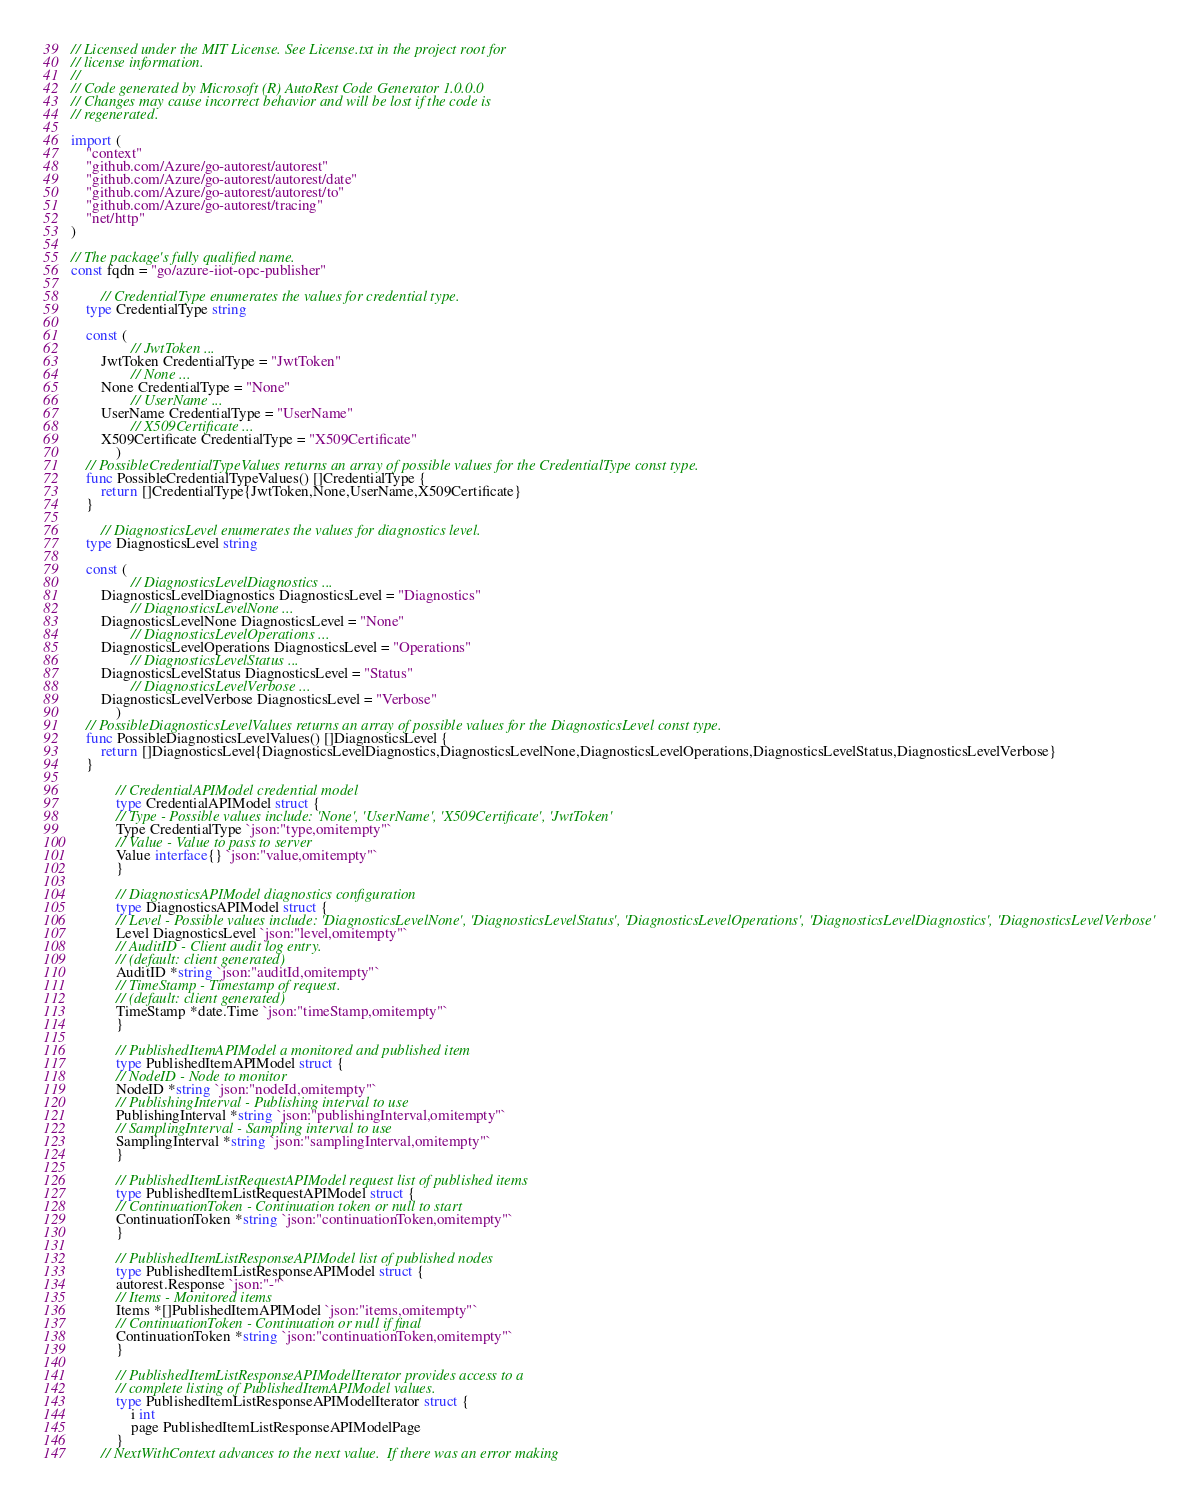<code> <loc_0><loc_0><loc_500><loc_500><_Go_>// Licensed under the MIT License. See License.txt in the project root for
// license information.
//
// Code generated by Microsoft (R) AutoRest Code Generator 1.0.0.0
// Changes may cause incorrect behavior and will be lost if the code is
// regenerated.

import (
    "context"
    "github.com/Azure/go-autorest/autorest"
    "github.com/Azure/go-autorest/autorest/date"
    "github.com/Azure/go-autorest/autorest/to"
    "github.com/Azure/go-autorest/tracing"
    "net/http"
)

// The package's fully qualified name.
const fqdn = "go/azure-iiot-opc-publisher"

        // CredentialType enumerates the values for credential type.
    type CredentialType string

    const (
                // JwtToken ...
        JwtToken CredentialType = "JwtToken"
                // None ...
        None CredentialType = "None"
                // UserName ...
        UserName CredentialType = "UserName"
                // X509Certificate ...
        X509Certificate CredentialType = "X509Certificate"
            )
    // PossibleCredentialTypeValues returns an array of possible values for the CredentialType const type.
    func PossibleCredentialTypeValues() []CredentialType {
        return []CredentialType{JwtToken,None,UserName,X509Certificate}
    }

        // DiagnosticsLevel enumerates the values for diagnostics level.
    type DiagnosticsLevel string

    const (
                // DiagnosticsLevelDiagnostics ...
        DiagnosticsLevelDiagnostics DiagnosticsLevel = "Diagnostics"
                // DiagnosticsLevelNone ...
        DiagnosticsLevelNone DiagnosticsLevel = "None"
                // DiagnosticsLevelOperations ...
        DiagnosticsLevelOperations DiagnosticsLevel = "Operations"
                // DiagnosticsLevelStatus ...
        DiagnosticsLevelStatus DiagnosticsLevel = "Status"
                // DiagnosticsLevelVerbose ...
        DiagnosticsLevelVerbose DiagnosticsLevel = "Verbose"
            )
    // PossibleDiagnosticsLevelValues returns an array of possible values for the DiagnosticsLevel const type.
    func PossibleDiagnosticsLevelValues() []DiagnosticsLevel {
        return []DiagnosticsLevel{DiagnosticsLevelDiagnostics,DiagnosticsLevelNone,DiagnosticsLevelOperations,DiagnosticsLevelStatus,DiagnosticsLevelVerbose}
    }

            // CredentialAPIModel credential model
            type CredentialAPIModel struct {
            // Type - Possible values include: 'None', 'UserName', 'X509Certificate', 'JwtToken'
            Type CredentialType `json:"type,omitempty"`
            // Value - Value to pass to server
            Value interface{} `json:"value,omitempty"`
            }

            // DiagnosticsAPIModel diagnostics configuration
            type DiagnosticsAPIModel struct {
            // Level - Possible values include: 'DiagnosticsLevelNone', 'DiagnosticsLevelStatus', 'DiagnosticsLevelOperations', 'DiagnosticsLevelDiagnostics', 'DiagnosticsLevelVerbose'
            Level DiagnosticsLevel `json:"level,omitempty"`
            // AuditID - Client audit log entry.
            // (default: client generated)
            AuditID *string `json:"auditId,omitempty"`
            // TimeStamp - Timestamp of request.
            // (default: client generated)
            TimeStamp *date.Time `json:"timeStamp,omitempty"`
            }

            // PublishedItemAPIModel a monitored and published item
            type PublishedItemAPIModel struct {
            // NodeID - Node to monitor
            NodeID *string `json:"nodeId,omitempty"`
            // PublishingInterval - Publishing interval to use
            PublishingInterval *string `json:"publishingInterval,omitempty"`
            // SamplingInterval - Sampling interval to use
            SamplingInterval *string `json:"samplingInterval,omitempty"`
            }

            // PublishedItemListRequestAPIModel request list of published items
            type PublishedItemListRequestAPIModel struct {
            // ContinuationToken - Continuation token or null to start
            ContinuationToken *string `json:"continuationToken,omitempty"`
            }

            // PublishedItemListResponseAPIModel list of published nodes
            type PublishedItemListResponseAPIModel struct {
            autorest.Response `json:"-"`
            // Items - Monitored items
            Items *[]PublishedItemAPIModel `json:"items,omitempty"`
            // ContinuationToken - Continuation or null if final
            ContinuationToken *string `json:"continuationToken,omitempty"`
            }

            // PublishedItemListResponseAPIModelIterator provides access to a
            // complete listing of PublishedItemAPIModel values.
            type PublishedItemListResponseAPIModelIterator struct {
                i int
                page PublishedItemListResponseAPIModelPage
            }
        // NextWithContext advances to the next value.  If there was an error making</code> 